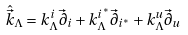Convert formula to latex. <formula><loc_0><loc_0><loc_500><loc_500>\hat { \vec { k } } _ { \Lambda } = k ^ { i } _ { \Lambda } \vec { \partial } _ { i } + k ^ { i ^ { * } } _ { \Lambda } \vec { \partial } _ { i ^ { * } } + k _ { \Lambda } ^ { u } \vec { \partial } _ { u }</formula> 